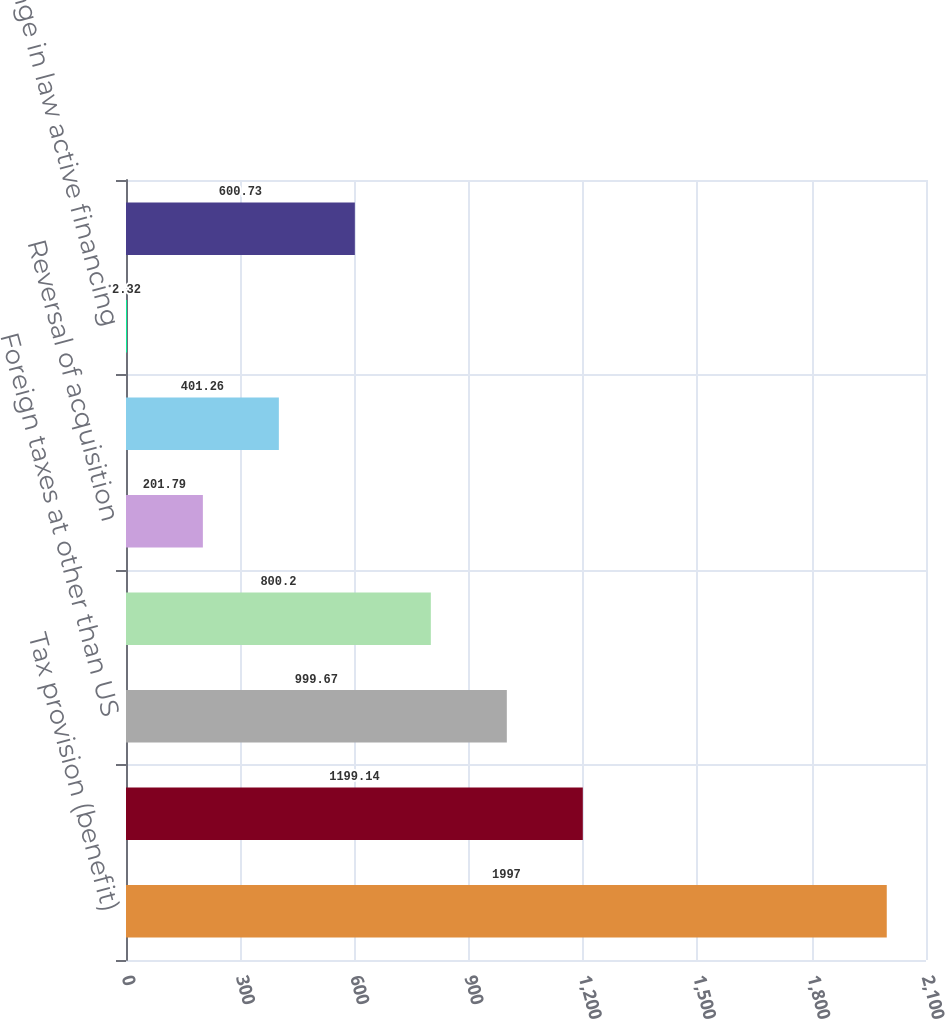Convert chart to OTSL. <chart><loc_0><loc_0><loc_500><loc_500><bar_chart><fcel>Tax provision (benefit)<fcel>Non-taxable investment income<fcel>Foreign taxes at other than US<fcel>Low income housing and other<fcel>Reversal of acquisition<fcel>Change in repatriation<fcel>Change in law active financing<fcel>Other<nl><fcel>1997<fcel>1199.14<fcel>999.67<fcel>800.2<fcel>201.79<fcel>401.26<fcel>2.32<fcel>600.73<nl></chart> 